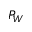<formula> <loc_0><loc_0><loc_500><loc_500>P _ { W }</formula> 